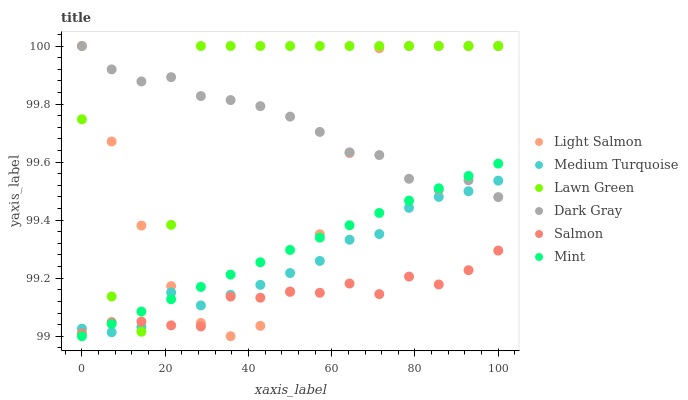Does Salmon have the minimum area under the curve?
Answer yes or no. Yes. Does Lawn Green have the maximum area under the curve?
Answer yes or no. Yes. Does Light Salmon have the minimum area under the curve?
Answer yes or no. No. Does Light Salmon have the maximum area under the curve?
Answer yes or no. No. Is Mint the smoothest?
Answer yes or no. Yes. Is Lawn Green the roughest?
Answer yes or no. Yes. Is Light Salmon the smoothest?
Answer yes or no. No. Is Light Salmon the roughest?
Answer yes or no. No. Does Mint have the lowest value?
Answer yes or no. Yes. Does Light Salmon have the lowest value?
Answer yes or no. No. Does Dark Gray have the highest value?
Answer yes or no. Yes. Does Salmon have the highest value?
Answer yes or no. No. Is Salmon less than Dark Gray?
Answer yes or no. Yes. Is Dark Gray greater than Salmon?
Answer yes or no. Yes. Does Medium Turquoise intersect Lawn Green?
Answer yes or no. Yes. Is Medium Turquoise less than Lawn Green?
Answer yes or no. No. Is Medium Turquoise greater than Lawn Green?
Answer yes or no. No. Does Salmon intersect Dark Gray?
Answer yes or no. No. 